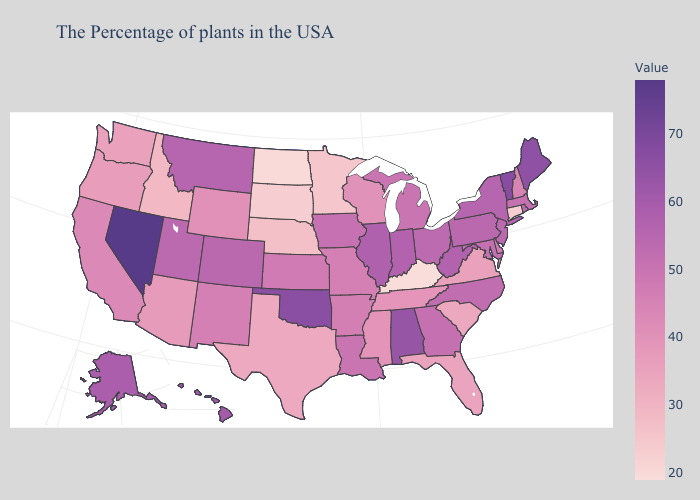Does Nevada have the highest value in the USA?
Concise answer only. Yes. Among the states that border Pennsylvania , which have the lowest value?
Answer briefly. Delaware. Among the states that border Ohio , does Indiana have the highest value?
Be succinct. Yes. Among the states that border Rhode Island , does Massachusetts have the lowest value?
Write a very short answer. No. Among the states that border Wisconsin , which have the lowest value?
Concise answer only. Minnesota. 